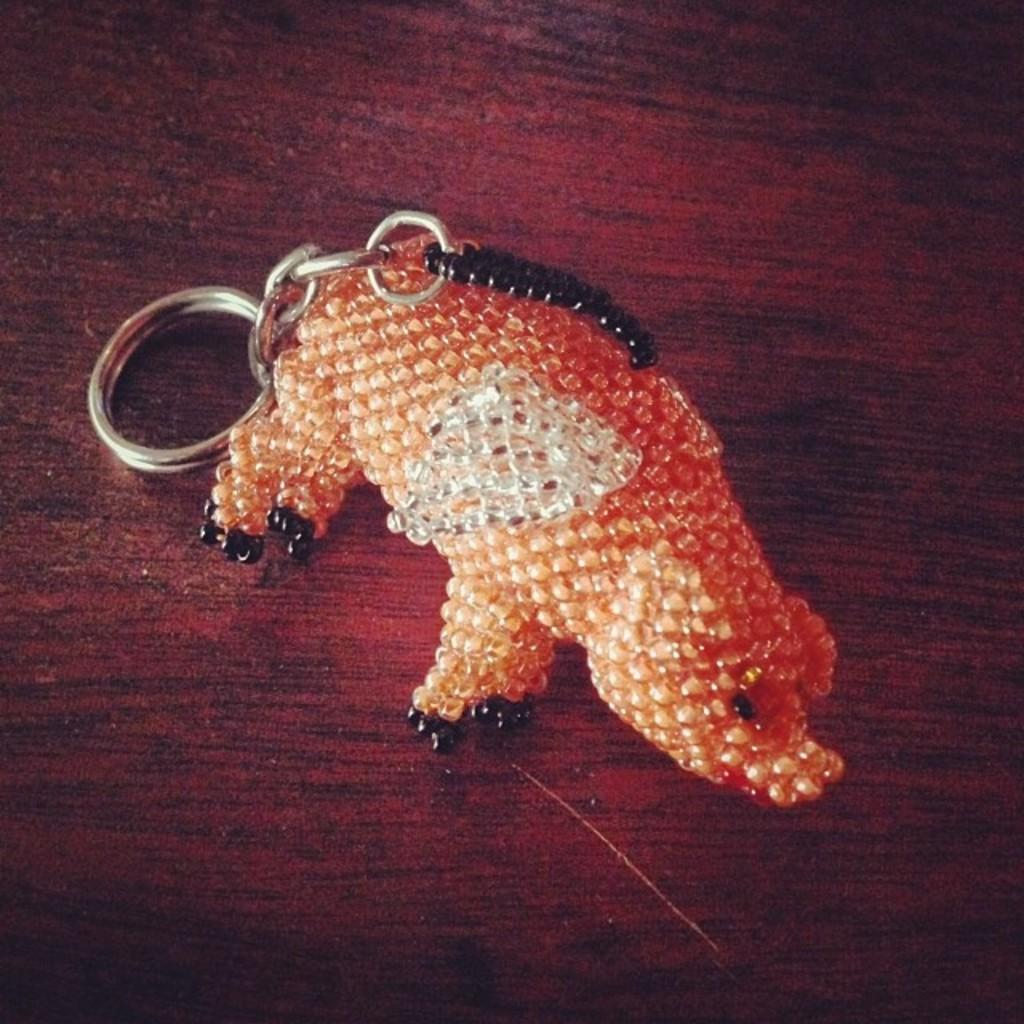What object can be seen in the image? There is a key chain in the image. What is the design of the key chain? The key chain has an animal design. On what surface is the key chain placed? The key chain is on a wooden surface. What type of instrument is being played by the animal on the key chain? There is no instrument being played by the animal on the key chain, as it is a static design and not a living creature. 